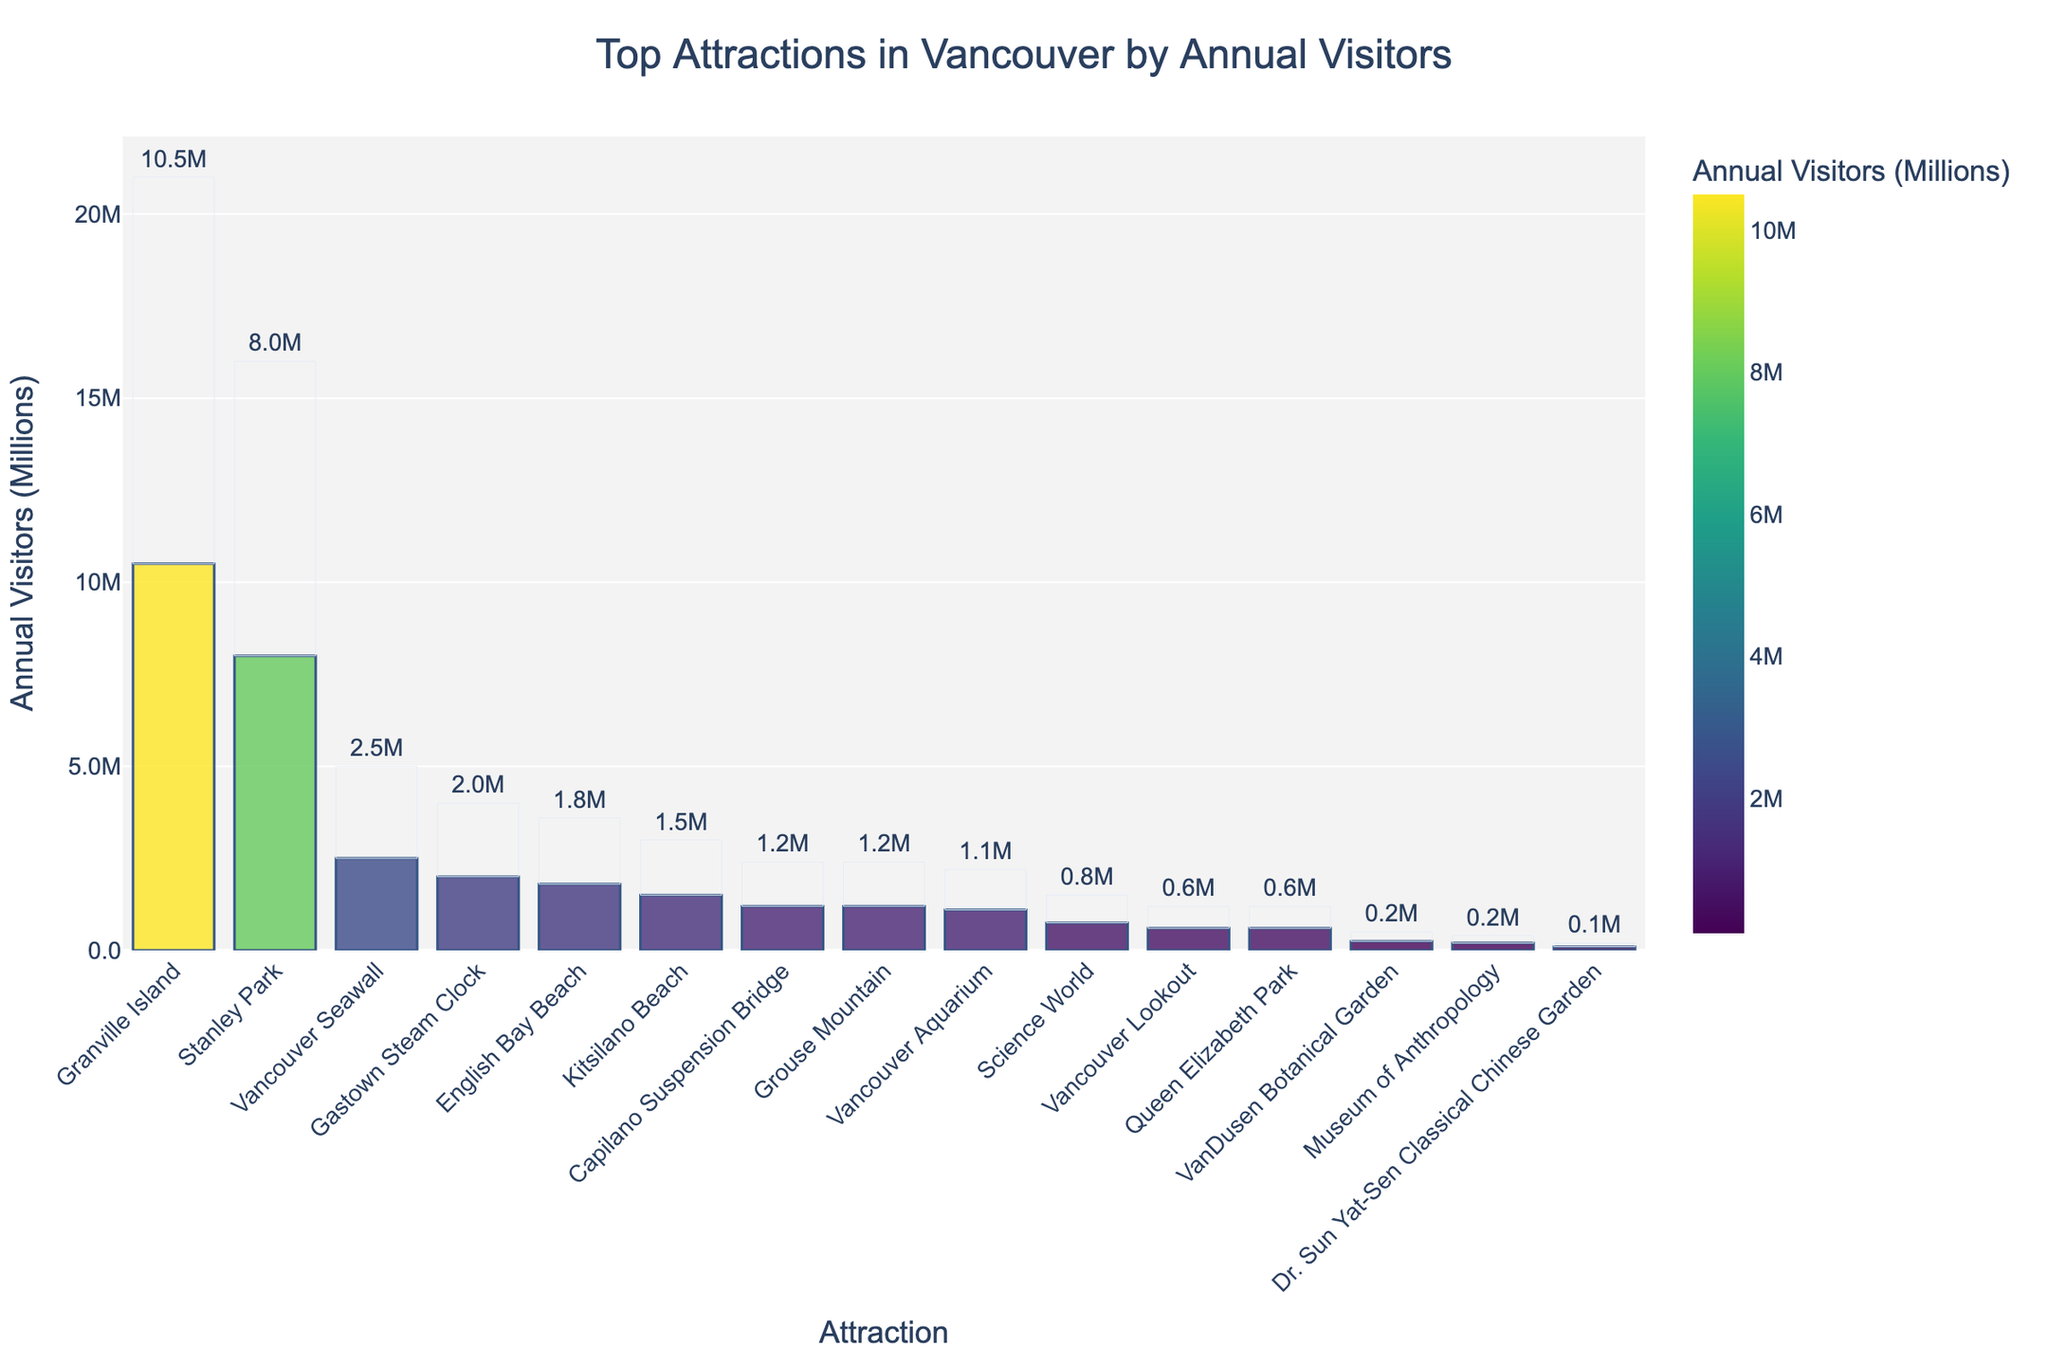What is the most visited attraction in Vancouver? Look for the bar with the largest height, which represents the most visited attraction. Granville Island has the tallest bar, indicating it has the highest annual visitor count.
Answer: Granville Island Which two attractions have the same number of annual visitors? Identify bars with the same height and check the labels. Both Capilano Suspension Bridge and Grouse Mountain have the same visitor count, 1,200,000.
Answer: Capilano Suspension Bridge and Grouse Mountain What is the difference in annual visitors between Stanley Park and Vancouver Aquarium? Find the bars representing Stanley Park and Vancouver Aquarium, note their visitor counts (8,000,000 and 1,100,000 respectively), then subtract the smaller number from the larger to find the difference.
Answer: 6,900,000 How many attractions have an annual visitor count less than 1,000,000? Count the bars that have a height less than the bar representing 1,000,000 visitors. These are Vancouver Aquarium, Science World, Vancouver Lookout, Museum of Anthropology, VanDusen Botanical Garden, and Dr. Sun Yat-Sen Classical Chinese Garden.
Answer: 6 Is Gastown Steam Clock more popular than Vancouver Seawall? Compare the heights of the bars for Gastown Steam Clock and Vancouver Seawall. Gastown Steam Clock has fewer annual visitors (2,000,000) compared to Vancouver Seawall (2,500,000).
Answer: No Which attraction has a visitor count closest to the average of Vancouver Aquarium and Science World? Calculate the average of Vancouver Aquarium (1,100,000) and Science World (750,000), which is (1,100,000 + 750,000) / 2 = 925,000. Identify the bar with a height close to 925,000; the closest is Science World.
Answer: Science World What is the total number of annual visitors for the top 3 most visited attractions? Sum the visitor counts of the top 3 attractions: Granville Island (10,500,000), Stanley Park (8,000,000), and Vancouver Seawall (2,500,000).
Answer: 21,000,000 Which attraction has the second fewest annual visitors? Identify the second shortest bar. The shortest bar is Dr. Sun Yat-Sen Classical Chinese Garden (100,000), and the second shortest is Museum of Anthropology (200,000).
Answer: Museum of Anthropology How does the visitor count of Kitsilano Beach compare to Queen Elizabeth Park? Compare the heights of the bars for Kitsilano Beach and Queen Elizabeth Park. Kitsilano Beach has a higher annual visitor count (1,500,000) than Queen Elizabeth Park (600,000).
Answer: Kitsilano Beach has more visitors What is the combined annual visitor count for Capilano Suspension Bridge and Grouse Mountain? Since both attractions have 1,200,000 visitors each, add these together to get the total. 1,200,000 + 1,200,000 = 2,400,000.
Answer: 2,400,000 